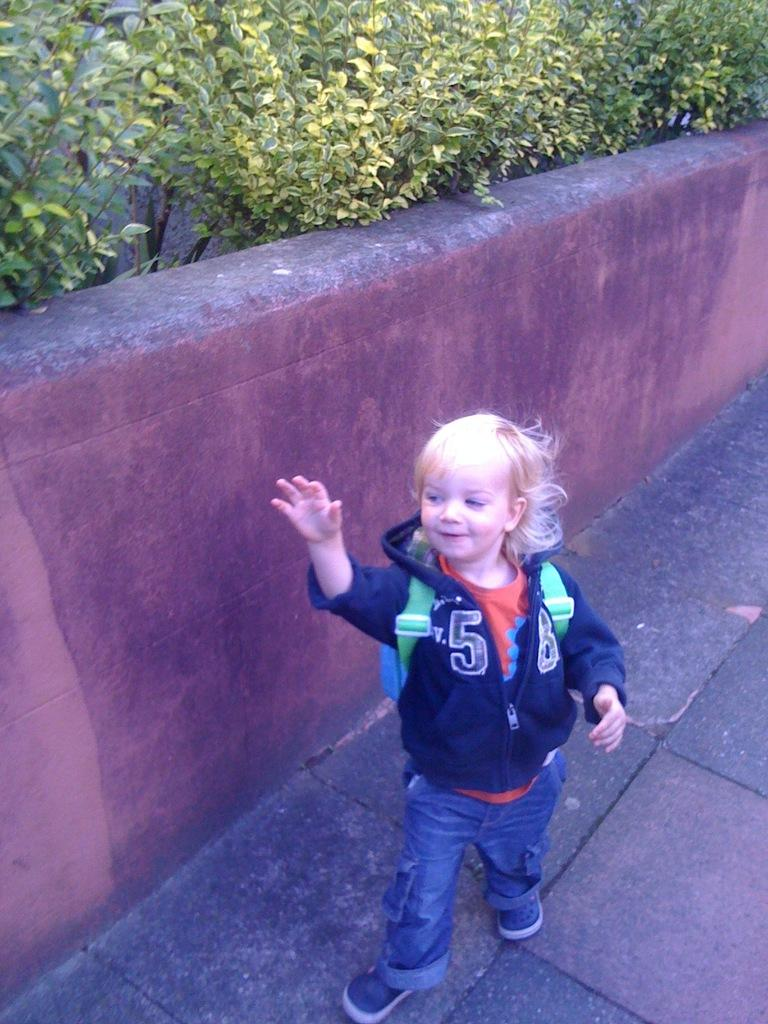<image>
Offer a succinct explanation of the picture presented. A child wearing a sweatshirt with the number 58 on it is standing in front of a wall. 